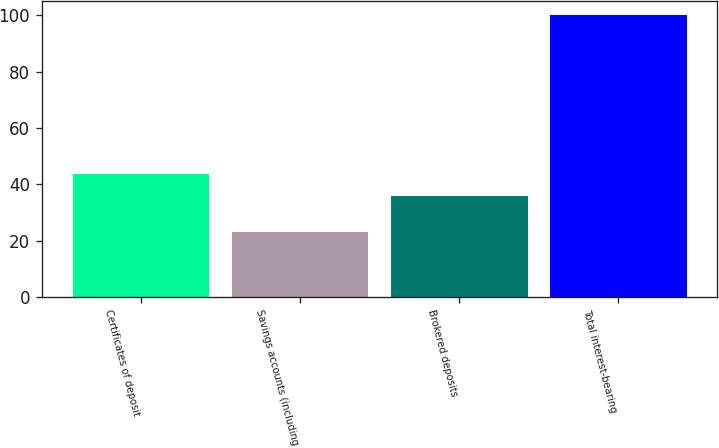<chart> <loc_0><loc_0><loc_500><loc_500><bar_chart><fcel>Certificates of deposit<fcel>Savings accounts (including<fcel>Brokered deposits<fcel>Total interest-bearing<nl><fcel>43.69<fcel>23.1<fcel>36<fcel>100<nl></chart> 